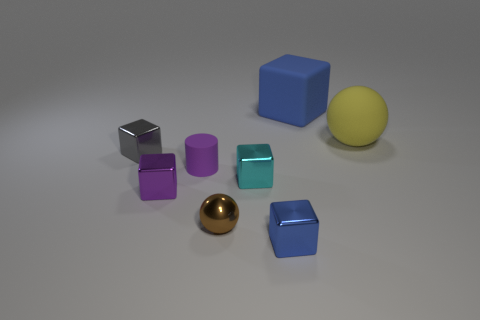There is a blue object that is in front of the cyan cube; is its size the same as the ball that is to the right of the large blue block?
Make the answer very short. No. What shape is the matte thing that is left of the ball left of the tiny blue metal block?
Your answer should be compact. Cylinder. There is a small gray cube; how many large blue rubber cubes are left of it?
Make the answer very short. 0. Are there any large red cylinders that have the same material as the large yellow object?
Your answer should be very brief. No. What material is the cylinder that is the same size as the blue metal block?
Make the answer very short. Rubber. There is a shiny cube that is both behind the small blue block and right of the rubber cylinder; what size is it?
Offer a very short reply. Small. There is a cube that is left of the tiny brown object and to the right of the gray cube; what color is it?
Provide a short and direct response. Purple. Is the number of tiny cyan objects that are behind the large cube less than the number of blue cubes that are right of the blue metallic object?
Ensure brevity in your answer.  Yes. How many purple metal things have the same shape as the gray metal object?
Make the answer very short. 1. What size is the purple thing that is made of the same material as the big yellow ball?
Ensure brevity in your answer.  Small. 